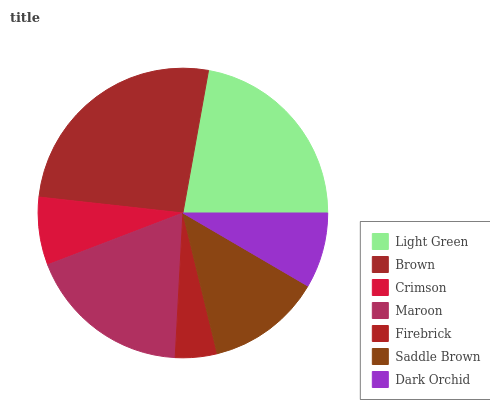Is Firebrick the minimum?
Answer yes or no. Yes. Is Brown the maximum?
Answer yes or no. Yes. Is Crimson the minimum?
Answer yes or no. No. Is Crimson the maximum?
Answer yes or no. No. Is Brown greater than Crimson?
Answer yes or no. Yes. Is Crimson less than Brown?
Answer yes or no. Yes. Is Crimson greater than Brown?
Answer yes or no. No. Is Brown less than Crimson?
Answer yes or no. No. Is Saddle Brown the high median?
Answer yes or no. Yes. Is Saddle Brown the low median?
Answer yes or no. Yes. Is Brown the high median?
Answer yes or no. No. Is Firebrick the low median?
Answer yes or no. No. 